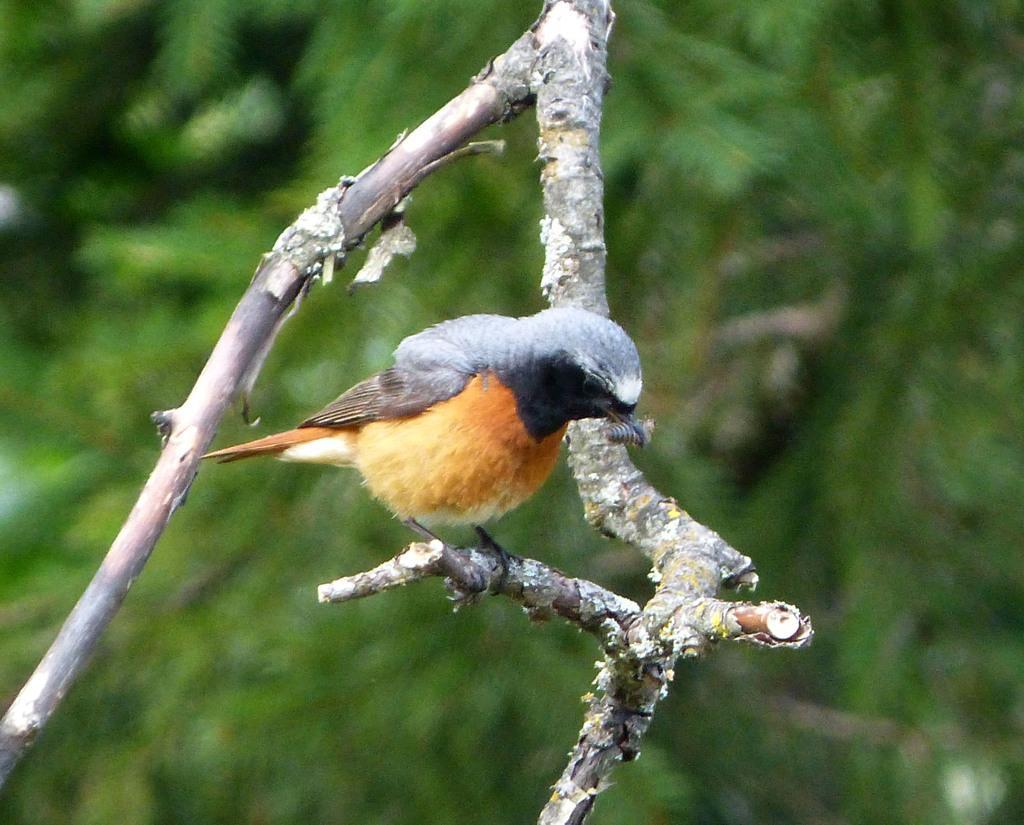How would you summarize this image in a sentence or two? In this image we can see a bird which is of yellow and black color is on the branch of a tree and in the background image is blur. 